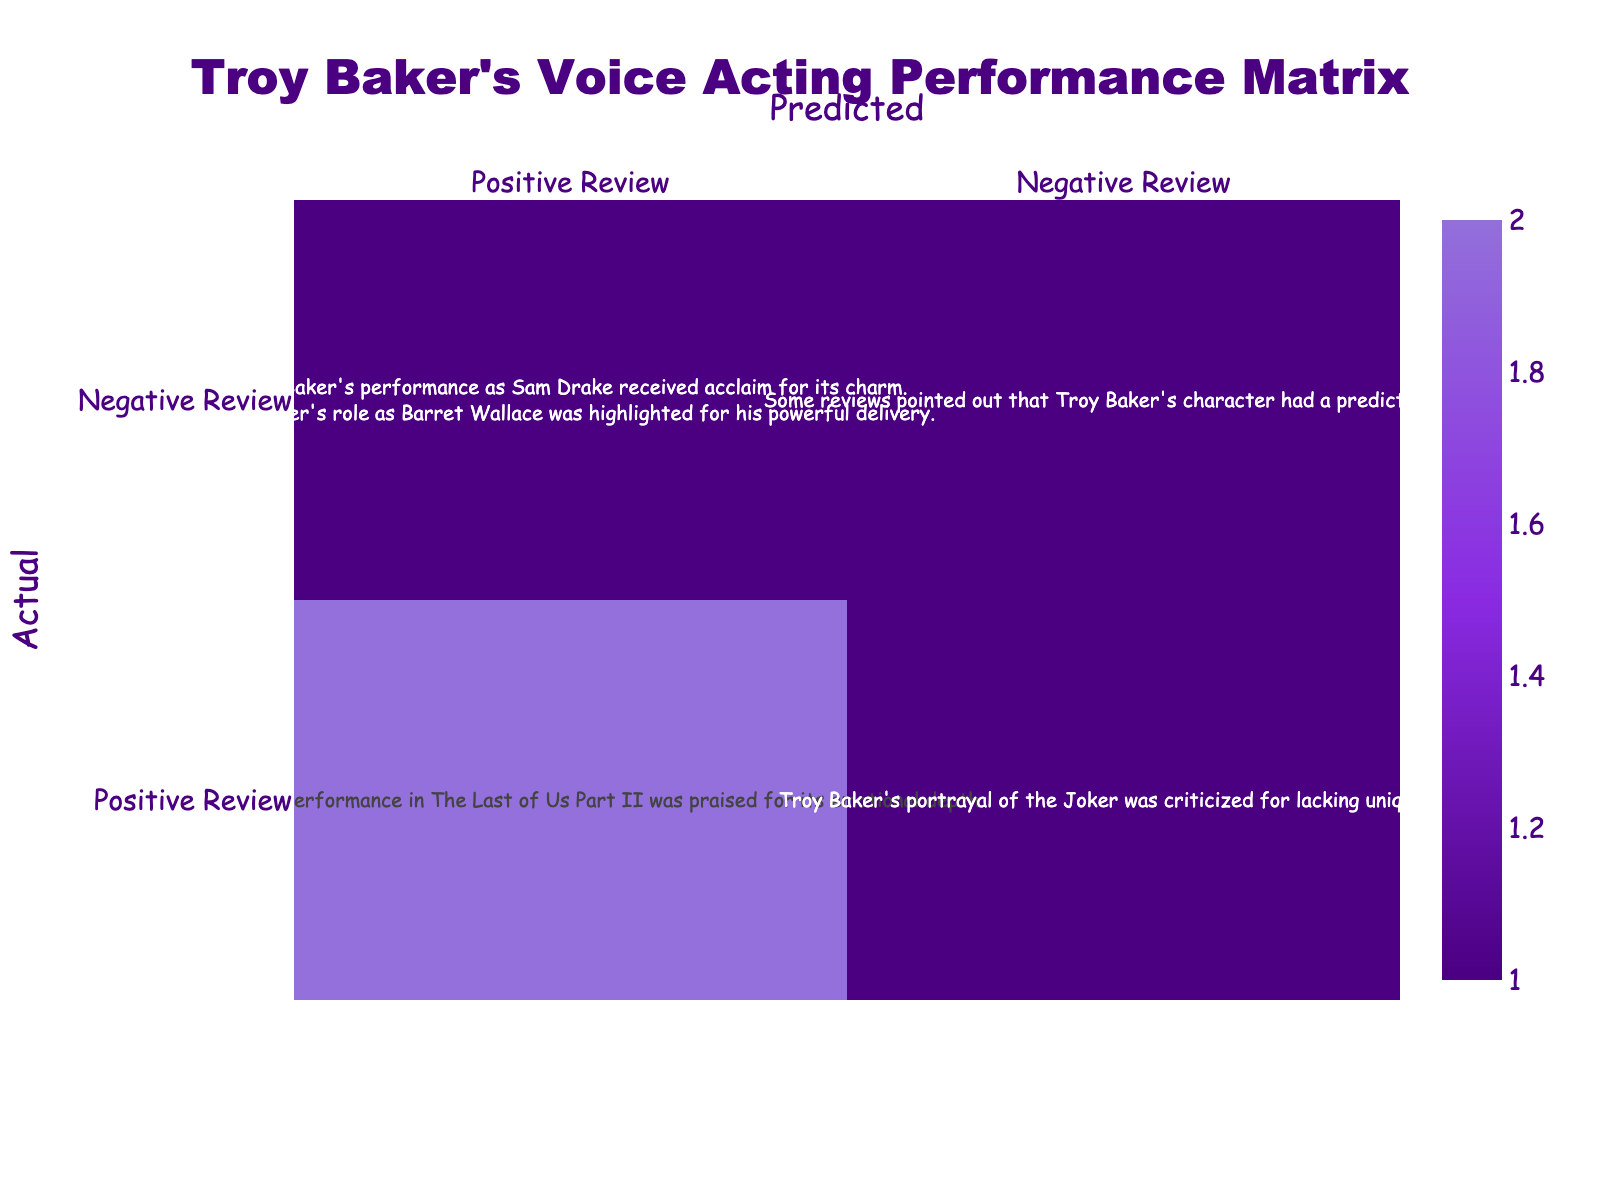What is the total number of positive reviews predicted for Troy Baker's performances? The table shows 4 entries where the predicted reviews are positive: The Last of Us Part II, Uncharted 4: A Thief's End, and Final Fantasy VII Remake, totaling 3 positive reviews predicted.
Answer: 3 Which performance received a negative review prediction? The table shows 2 entries under predicted negative reviews: Batman: Arkham City and Infamous: Second Son. Batman: Arkham City was explicitly identified as a predicted negative review.
Answer: Batman: Arkham City What is the combined number of negative reviews and positive reviews predicted for Troy Baker? To find the combined total, we add the predicted negative reviews (2) and predicted positive reviews (4), leading to a total of 6 reviews.
Answer: 6 Did Troy Baker's performance in The Last of Us Part II receive a negative review? The table indicates The Last of Us Part II is under predicted positive reviews, so it did not receive a negative review.
Answer: No How many performances in total were rated positively by critics in the actual reviews? The table lists 4 performances under actual positive reviews (The Last of Us Part II, Uncharted 4: A Thief's End, and Final Fantasy VII Remake), giving a total of 4 performances reviewed positively.
Answer: 4 Are there any performances where both positive and negative reviews were predicted? The table does not present any performance with both predicted positive and negative reviews, as each performance is assigned only one review type.
Answer: No What can you say about the performance of Troy Baker in Infamous: Second Son based on the predictions? Infamous: Second Son is listed as a predicted negative review, indicating that it was not well-received in terms of his performance.
Answer: Negative What is the difference in the predicted number of positive reviews and negative reviews for Troy Baker? The predicted positive reviews amount to 4, while the negative reviews amount to 2, creating a difference of 2 (4 - 2 = 2).
Answer: 2 